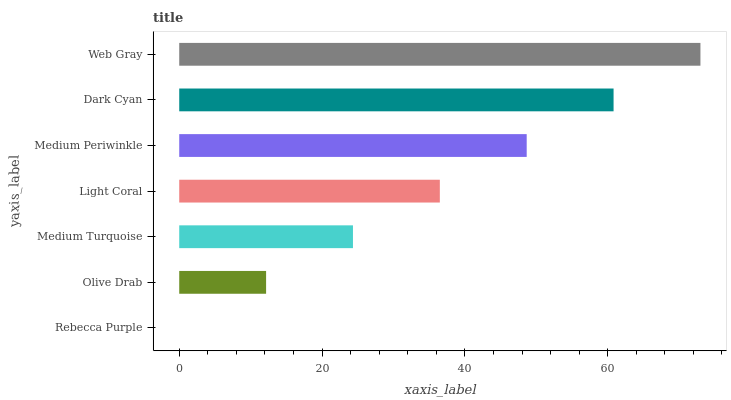Is Rebecca Purple the minimum?
Answer yes or no. Yes. Is Web Gray the maximum?
Answer yes or no. Yes. Is Olive Drab the minimum?
Answer yes or no. No. Is Olive Drab the maximum?
Answer yes or no. No. Is Olive Drab greater than Rebecca Purple?
Answer yes or no. Yes. Is Rebecca Purple less than Olive Drab?
Answer yes or no. Yes. Is Rebecca Purple greater than Olive Drab?
Answer yes or no. No. Is Olive Drab less than Rebecca Purple?
Answer yes or no. No. Is Light Coral the high median?
Answer yes or no. Yes. Is Light Coral the low median?
Answer yes or no. Yes. Is Medium Periwinkle the high median?
Answer yes or no. No. Is Rebecca Purple the low median?
Answer yes or no. No. 